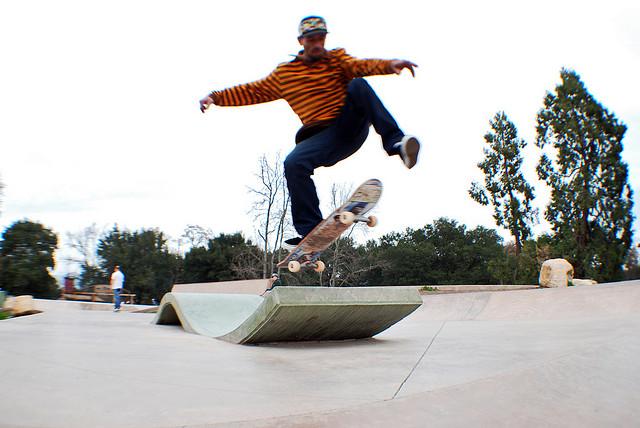What color is the skateboard?
Give a very brief answer. White. Is this a skateboard park?
Give a very brief answer. Yes. What is he wearing on his head?
Write a very short answer. Hat. 